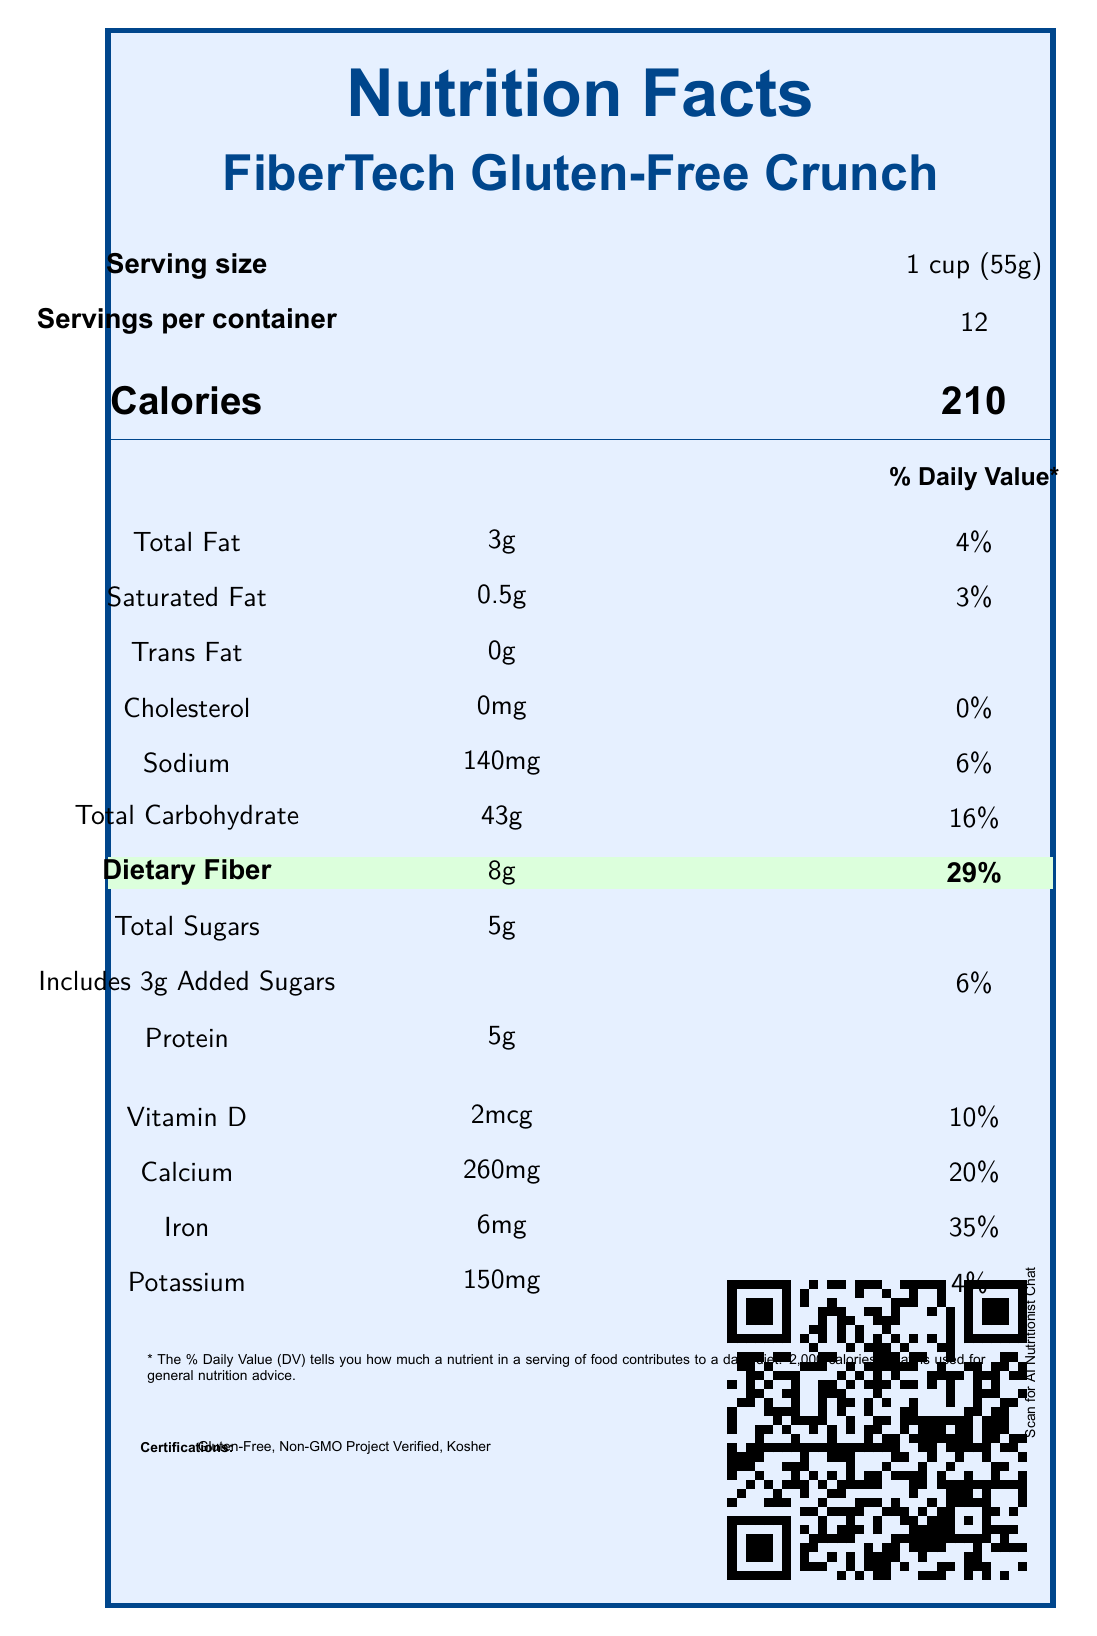What is the serving size for FiberTech Gluten-Free Crunch? The serving size is clearly mentioned in the serving information section of the document.
Answer: 1 cup (55g) How many calories are there per serving? The calories per serving are listed at the top portion of the nutrient table.
Answer: 210 What percentage of the daily value of iron does one serving provide? The daily value percentage for iron is listed in the vitamins and mineral information section.
Answer: 35% How much dietary fiber is in one serving, and what percentage of the daily value does it represent? The dietary fiber amount (8g) and its daily value percentage (29%) are highlighted in the nutrition table.
Answer: 8g, 29% What is the total amount of sugars in one serving, and how much of that is added sugars? The document states that there are 5g of total sugars which includes 3g of added sugars.
Answer: 5g total, including 3g added sugars Is the cereal manufactured in a facility that processes tree nuts and soy? This information is provided in the allergen information section at the bottom of the document.
Answer: Yes Which university collaborated on the research study associated with this cereal? The research collaboration section mentions Stanford University.
Answer: Stanford University What is the main sustainability benefit of the packaging material? A. It's biodegradable B. It uses 50% less plastic C. It's made from 100% recycled paperboard The sustainability information section specifies that the packaging is made from 100% recycled paperboard.
Answer: C Which certifications does this cereal have? A. Organic, Gluten-Free B. Non-GMO Project Verified, Organic C. Non-GMO Project Verified, Gluten-Free, Kosher The certification section lists these three certifications.
Answer: C Is there any NFC (Near Field Communication) feature available with this cereal? The digital integration section mentions "Tap for nutritional analysis," indicating an NFC tag.
Answer: Yes What are the accessibility features provided for this product's packaging? The accessibility features section lists all these attributes.
Answer: Braille Labeling, High-Contrast Colors, Large Font (14pt minimum) Summarize the main features and nutritional highlights of FiberTech Gluten-Free Crunch. This summary captures key nutritional values, certifications, and special features present in the document, providing a well-rounded view of what FiberTech Gluten-Free Crunch offers.
Answer: FiberTech Gluten-Free Crunch offers 210 calories per 1 cup serving, with 8g of dietary fiber (29% DV). It's gluten-free, kosher, and non-GMO. The product has several vitamins and minerals like calcium (20% DV) and iron (35% DV). It includes sustainability features like 100% recycled packaging and accessibility features like braille labeling. It also has smart packaging integrations and a research collaboration with Stanford University. Does the document provide specific information on the price of the cereal? The document does not mention the price of the cereal.
Answer: Not enough information 